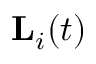Convert formula to latex. <formula><loc_0><loc_0><loc_500><loc_500>L _ { i } ( t )</formula> 